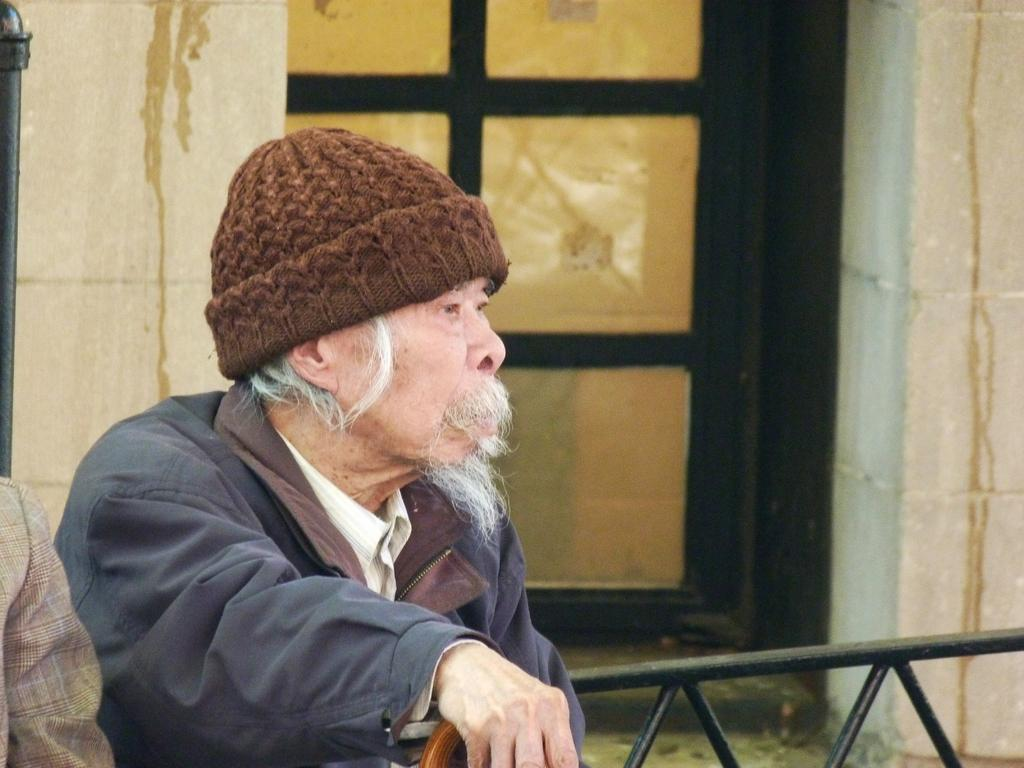How many people are in the image? There are two people in the image. What is the appearance of one of the people? One person is wearing a jacket and a cap. What is the person holding? The person is holding an object. What can be seen in the background of the image? There are rods, walls, and a door in the background of the image. What type of toys are the people playing with in the image? There are no toys present in the image. What does the dad say to the other person in the image? There is no indication of a dad or any spoken words in the image. 